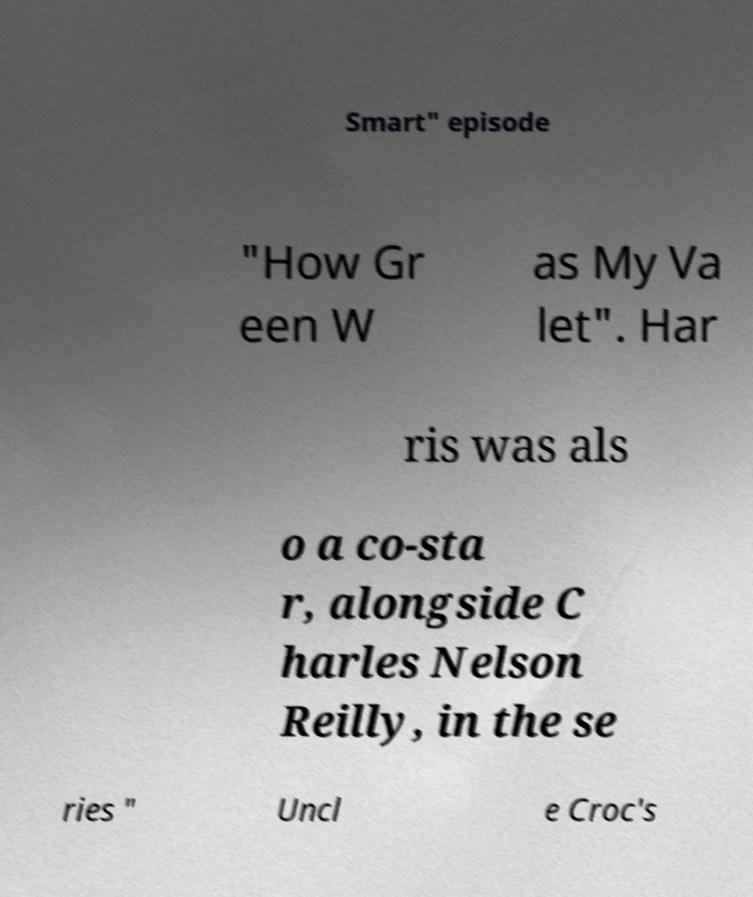Could you extract and type out the text from this image? Smart" episode "How Gr een W as My Va let". Har ris was als o a co-sta r, alongside C harles Nelson Reilly, in the se ries " Uncl e Croc's 